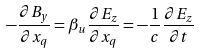Convert formula to latex. <formula><loc_0><loc_0><loc_500><loc_500>- \frac { \partial B _ { y } } { \partial x _ { q } } = \beta _ { u } \frac { \partial E _ { z } } { \partial x _ { q } } = - \frac { 1 } { c } \frac { \partial E _ { z } } { \partial t }</formula> 